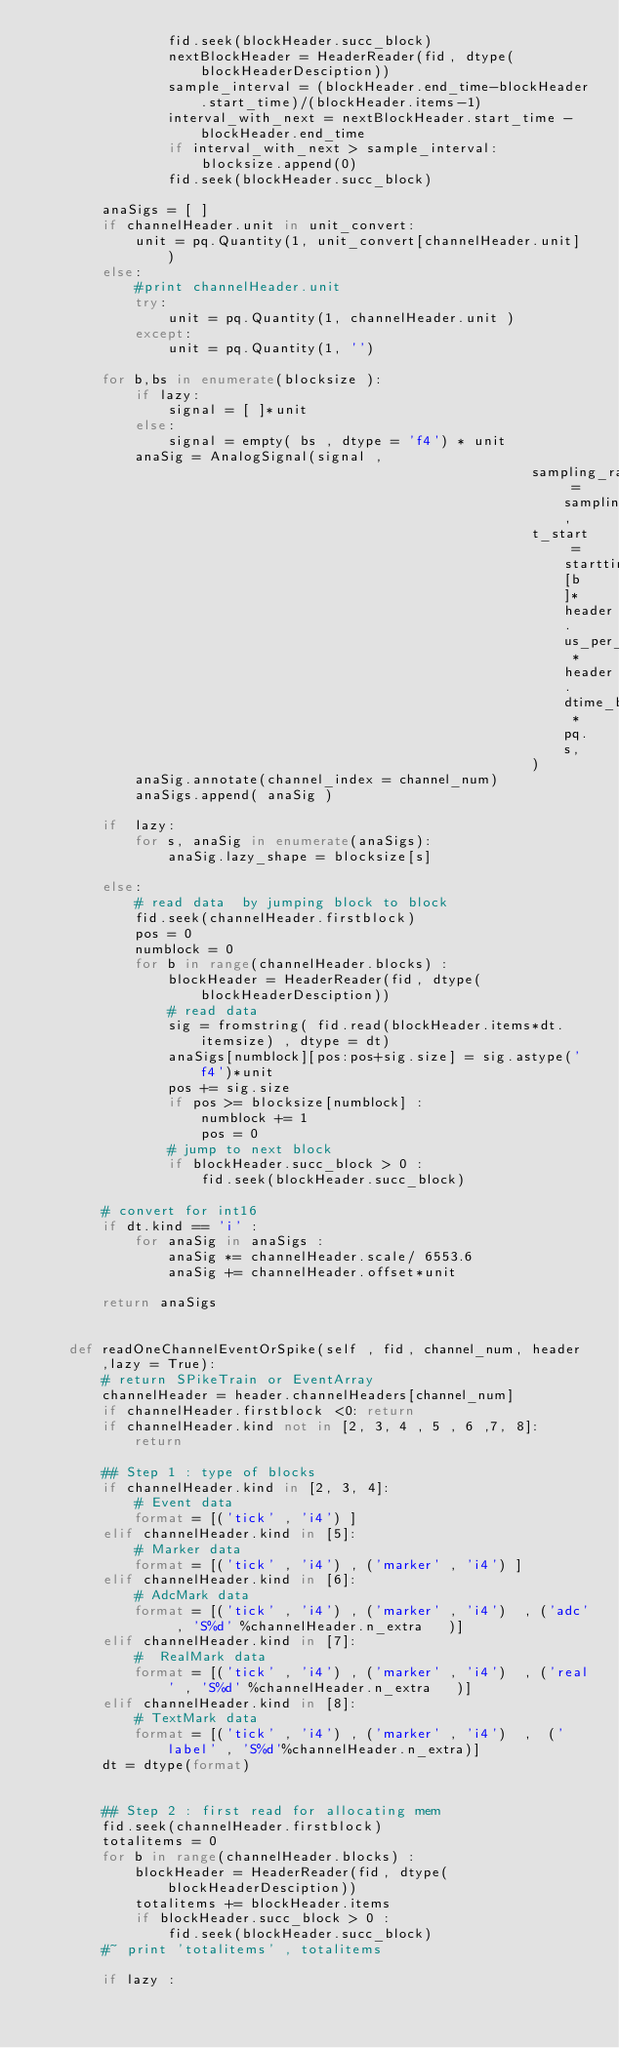Convert code to text. <code><loc_0><loc_0><loc_500><loc_500><_Python_>                fid.seek(blockHeader.succ_block)
                nextBlockHeader = HeaderReader(fid, dtype(blockHeaderDesciption))
                sample_interval = (blockHeader.end_time-blockHeader.start_time)/(blockHeader.items-1)
                interval_with_next = nextBlockHeader.start_time - blockHeader.end_time
                if interval_with_next > sample_interval:
                    blocksize.append(0)
                fid.seek(blockHeader.succ_block)

        anaSigs = [ ]
        if channelHeader.unit in unit_convert:
            unit = pq.Quantity(1, unit_convert[channelHeader.unit] )
        else:
            #print channelHeader.unit
            try:
                unit = pq.Quantity(1, channelHeader.unit )
            except:
                unit = pq.Quantity(1, '')

        for b,bs in enumerate(blocksize ):
            if lazy:
                signal = [ ]*unit
            else:
                signal = empty( bs , dtype = 'f4') * unit
            anaSig = AnalogSignal(signal ,
                                                            sampling_rate = sampling_rate,
                                                            t_start = starttimes[b]*header.us_per_time * header.dtime_base * pq.s,
                                                            )
            anaSig.annotate(channel_index = channel_num)
            anaSigs.append( anaSig )

        if  lazy:
            for s, anaSig in enumerate(anaSigs):
                anaSig.lazy_shape = blocksize[s]

        else:
            # read data  by jumping block to block
            fid.seek(channelHeader.firstblock)
            pos = 0
            numblock = 0
            for b in range(channelHeader.blocks) :
                blockHeader = HeaderReader(fid, dtype(blockHeaderDesciption))
                # read data
                sig = fromstring( fid.read(blockHeader.items*dt.itemsize) , dtype = dt)
                anaSigs[numblock][pos:pos+sig.size] = sig.astype('f4')*unit
                pos += sig.size
                if pos >= blocksize[numblock] :
                    numblock += 1
                    pos = 0
                # jump to next block
                if blockHeader.succ_block > 0 :
                    fid.seek(blockHeader.succ_block)

        # convert for int16
        if dt.kind == 'i' :
            for anaSig in anaSigs :
                anaSig *= channelHeader.scale/ 6553.6
                anaSig += channelHeader.offset*unit

        return anaSigs


    def readOneChannelEventOrSpike(self , fid, channel_num, header ,lazy = True):
        # return SPikeTrain or EventArray
        channelHeader = header.channelHeaders[channel_num]
        if channelHeader.firstblock <0: return
        if channelHeader.kind not in [2, 3, 4 , 5 , 6 ,7, 8]: return

        ## Step 1 : type of blocks
        if channelHeader.kind in [2, 3, 4]:
            # Event data
            format = [('tick' , 'i4') ]
        elif channelHeader.kind in [5]:
            # Marker data
            format = [('tick' , 'i4') , ('marker' , 'i4') ]
        elif channelHeader.kind in [6]:
            # AdcMark data
            format = [('tick' , 'i4') , ('marker' , 'i4')  , ('adc' , 'S%d' %channelHeader.n_extra   )]
        elif channelHeader.kind in [7]:
            #  RealMark data
            format = [('tick' , 'i4') , ('marker' , 'i4')  , ('real' , 'S%d' %channelHeader.n_extra   )]
        elif channelHeader.kind in [8]:
            # TextMark data
            format = [('tick' , 'i4') , ('marker' , 'i4')  ,  ('label' , 'S%d'%channelHeader.n_extra)]
        dt = dtype(format)


        ## Step 2 : first read for allocating mem
        fid.seek(channelHeader.firstblock)
        totalitems = 0
        for b in range(channelHeader.blocks) :
            blockHeader = HeaderReader(fid, dtype(blockHeaderDesciption))
            totalitems += blockHeader.items
            if blockHeader.succ_block > 0 :
                fid.seek(blockHeader.succ_block)
        #~ print 'totalitems' , totalitems

        if lazy :</code> 